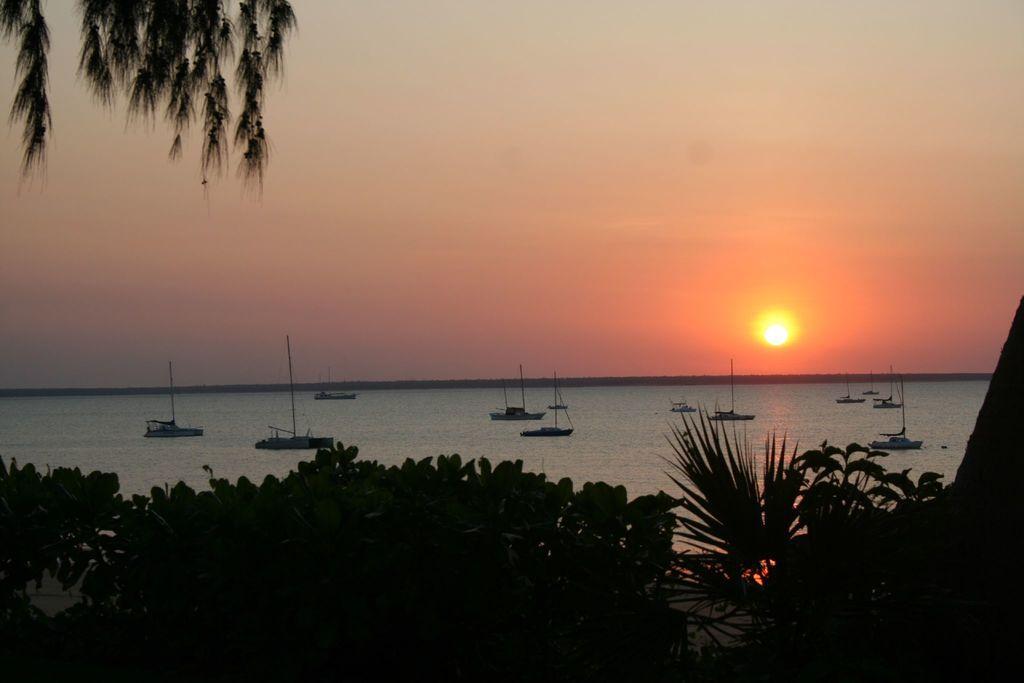In one or two sentences, can you explain what this image depicts? In this image I see number of trees and in the background I see the water on which there are few boats and I see the sky and I see the sun over here. 